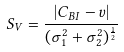<formula> <loc_0><loc_0><loc_500><loc_500>\ S _ { V } = \frac { | C _ { B I } - v | } { ( \sigma _ { 1 } ^ { 2 } + \sigma _ { 2 } ^ { 2 } ) ^ { \frac { 1 } { 2 } } }</formula> 